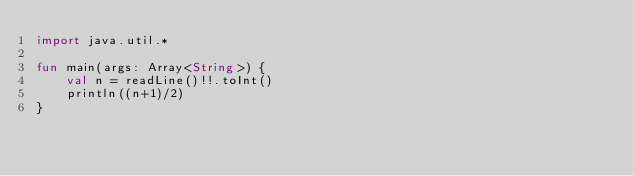<code> <loc_0><loc_0><loc_500><loc_500><_Kotlin_>import java.util.*

fun main(args: Array<String>) {
    val n = readLine()!!.toInt()
    println((n+1)/2)
}</code> 